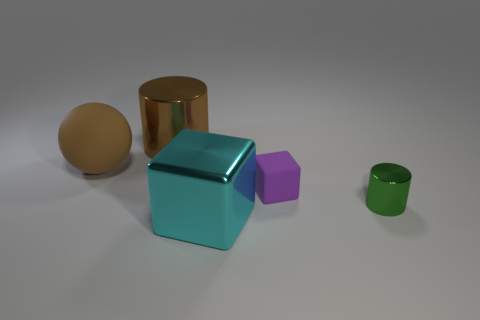There is a rubber object right of the shiny object behind the metal object to the right of the purple matte cube; what color is it?
Your answer should be very brief. Purple. Is the number of large brown metallic objects the same as the number of big blue matte objects?
Keep it short and to the point. No. What number of cyan objects are either big matte balls or big things?
Provide a succinct answer. 1. How many small shiny things are the same shape as the large brown matte thing?
Make the answer very short. 0. There is a brown metal thing that is the same size as the sphere; what shape is it?
Your answer should be very brief. Cylinder. Are there any tiny green shiny cylinders in front of the brown rubber object?
Offer a terse response. Yes. Are there any tiny green cylinders that are in front of the metallic cylinder that is in front of the large brown shiny thing?
Make the answer very short. No. Are there fewer cyan shiny things that are behind the tiny purple object than small rubber cubes left of the green metallic cylinder?
Make the answer very short. Yes. Is there any other thing that has the same size as the green shiny cylinder?
Offer a very short reply. Yes. What is the shape of the tiny green metallic thing?
Make the answer very short. Cylinder. 